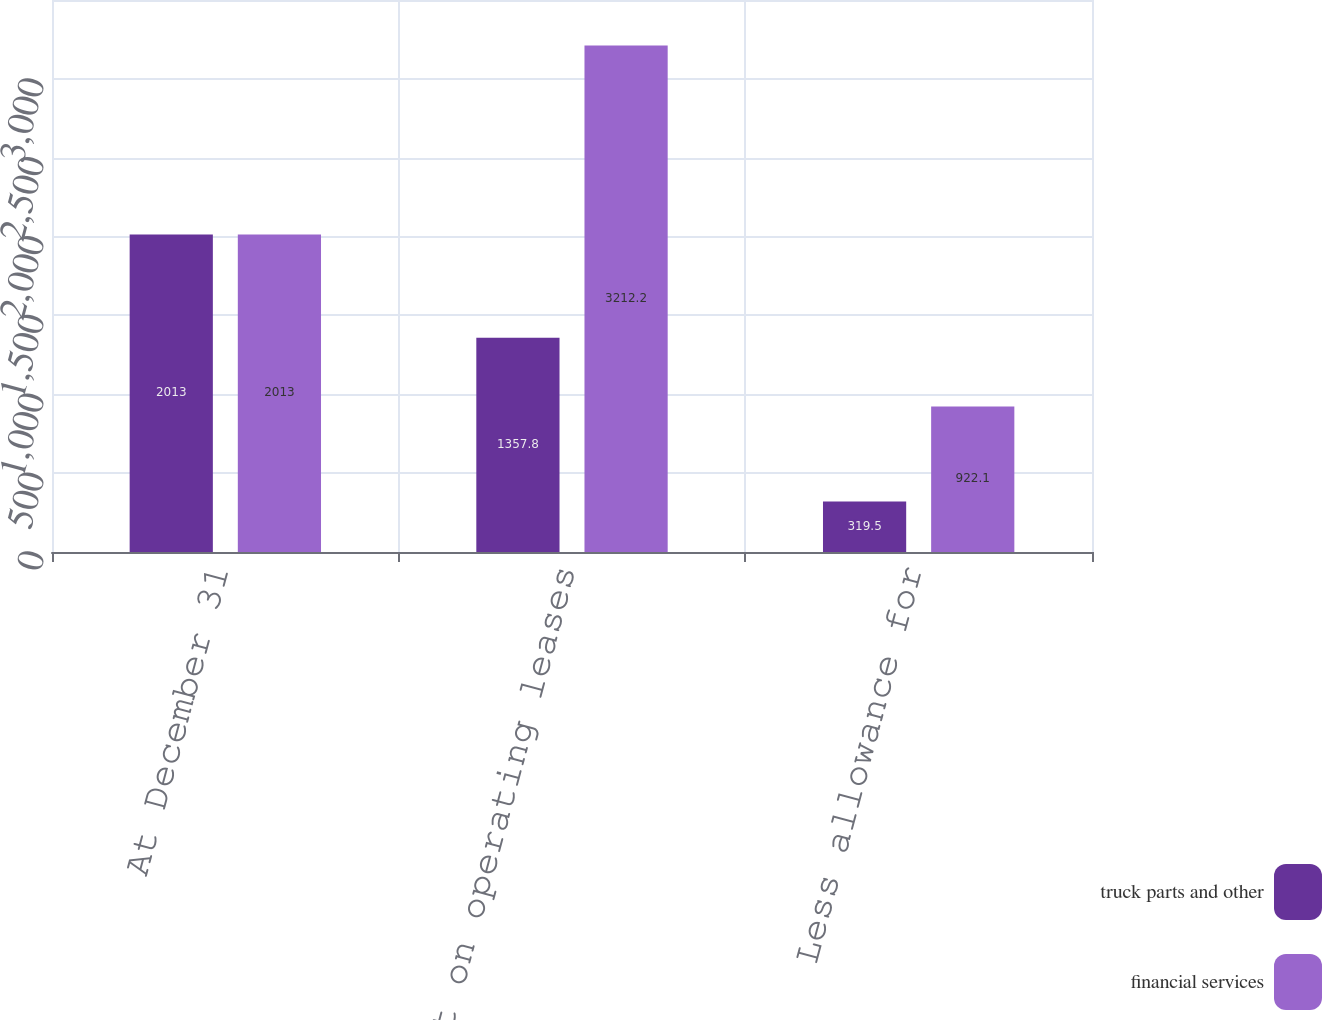Convert chart to OTSL. <chart><loc_0><loc_0><loc_500><loc_500><stacked_bar_chart><ecel><fcel>At December 31<fcel>Equipment on operating leases<fcel>Less allowance for<nl><fcel>truck parts and other<fcel>2013<fcel>1357.8<fcel>319.5<nl><fcel>financial services<fcel>2013<fcel>3212.2<fcel>922.1<nl></chart> 